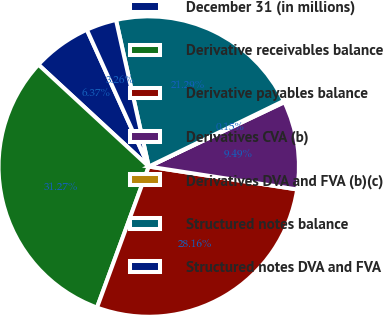<chart> <loc_0><loc_0><loc_500><loc_500><pie_chart><fcel>December 31 (in millions)<fcel>Derivative receivables balance<fcel>Derivative payables balance<fcel>Derivatives CVA (b)<fcel>Derivatives DVA and FVA (b)(c)<fcel>Structured notes balance<fcel>Structured notes DVA and FVA<nl><fcel>6.37%<fcel>31.27%<fcel>28.16%<fcel>9.49%<fcel>0.15%<fcel>21.29%<fcel>3.26%<nl></chart> 